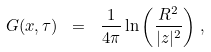Convert formula to latex. <formula><loc_0><loc_0><loc_500><loc_500>G ( x , \tau ) \ = \ \frac { 1 } { 4 \pi } \ln \left ( \frac { R ^ { 2 } } { | z | ^ { 2 } } \right ) \, ,</formula> 